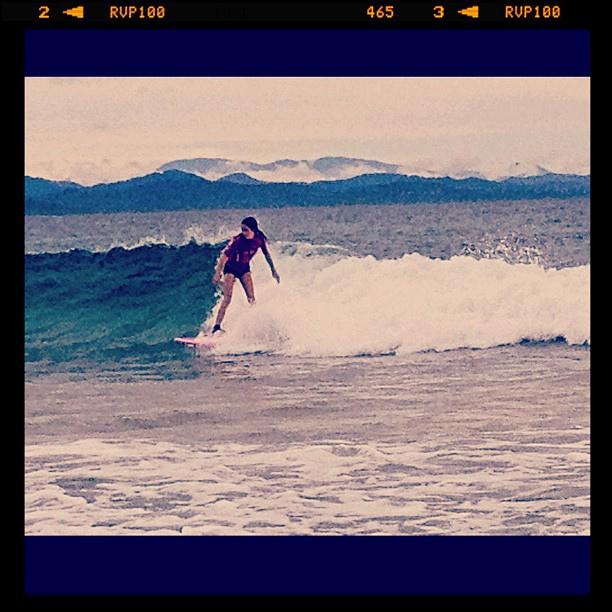Is the wave big or small?
Keep it brief. Small. What motion is the water?
Write a very short answer. Wave. Are there ships on the water?
Keep it brief. No. Is this picture taken with Instagram?
Keep it brief. Yes. Has this photo been processed?
Write a very short answer. Yes. What gender is the surfer?
Keep it brief. Female. Is the water calm or rough?
Short answer required. Rough. 